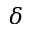<formula> <loc_0><loc_0><loc_500><loc_500>\delta</formula> 